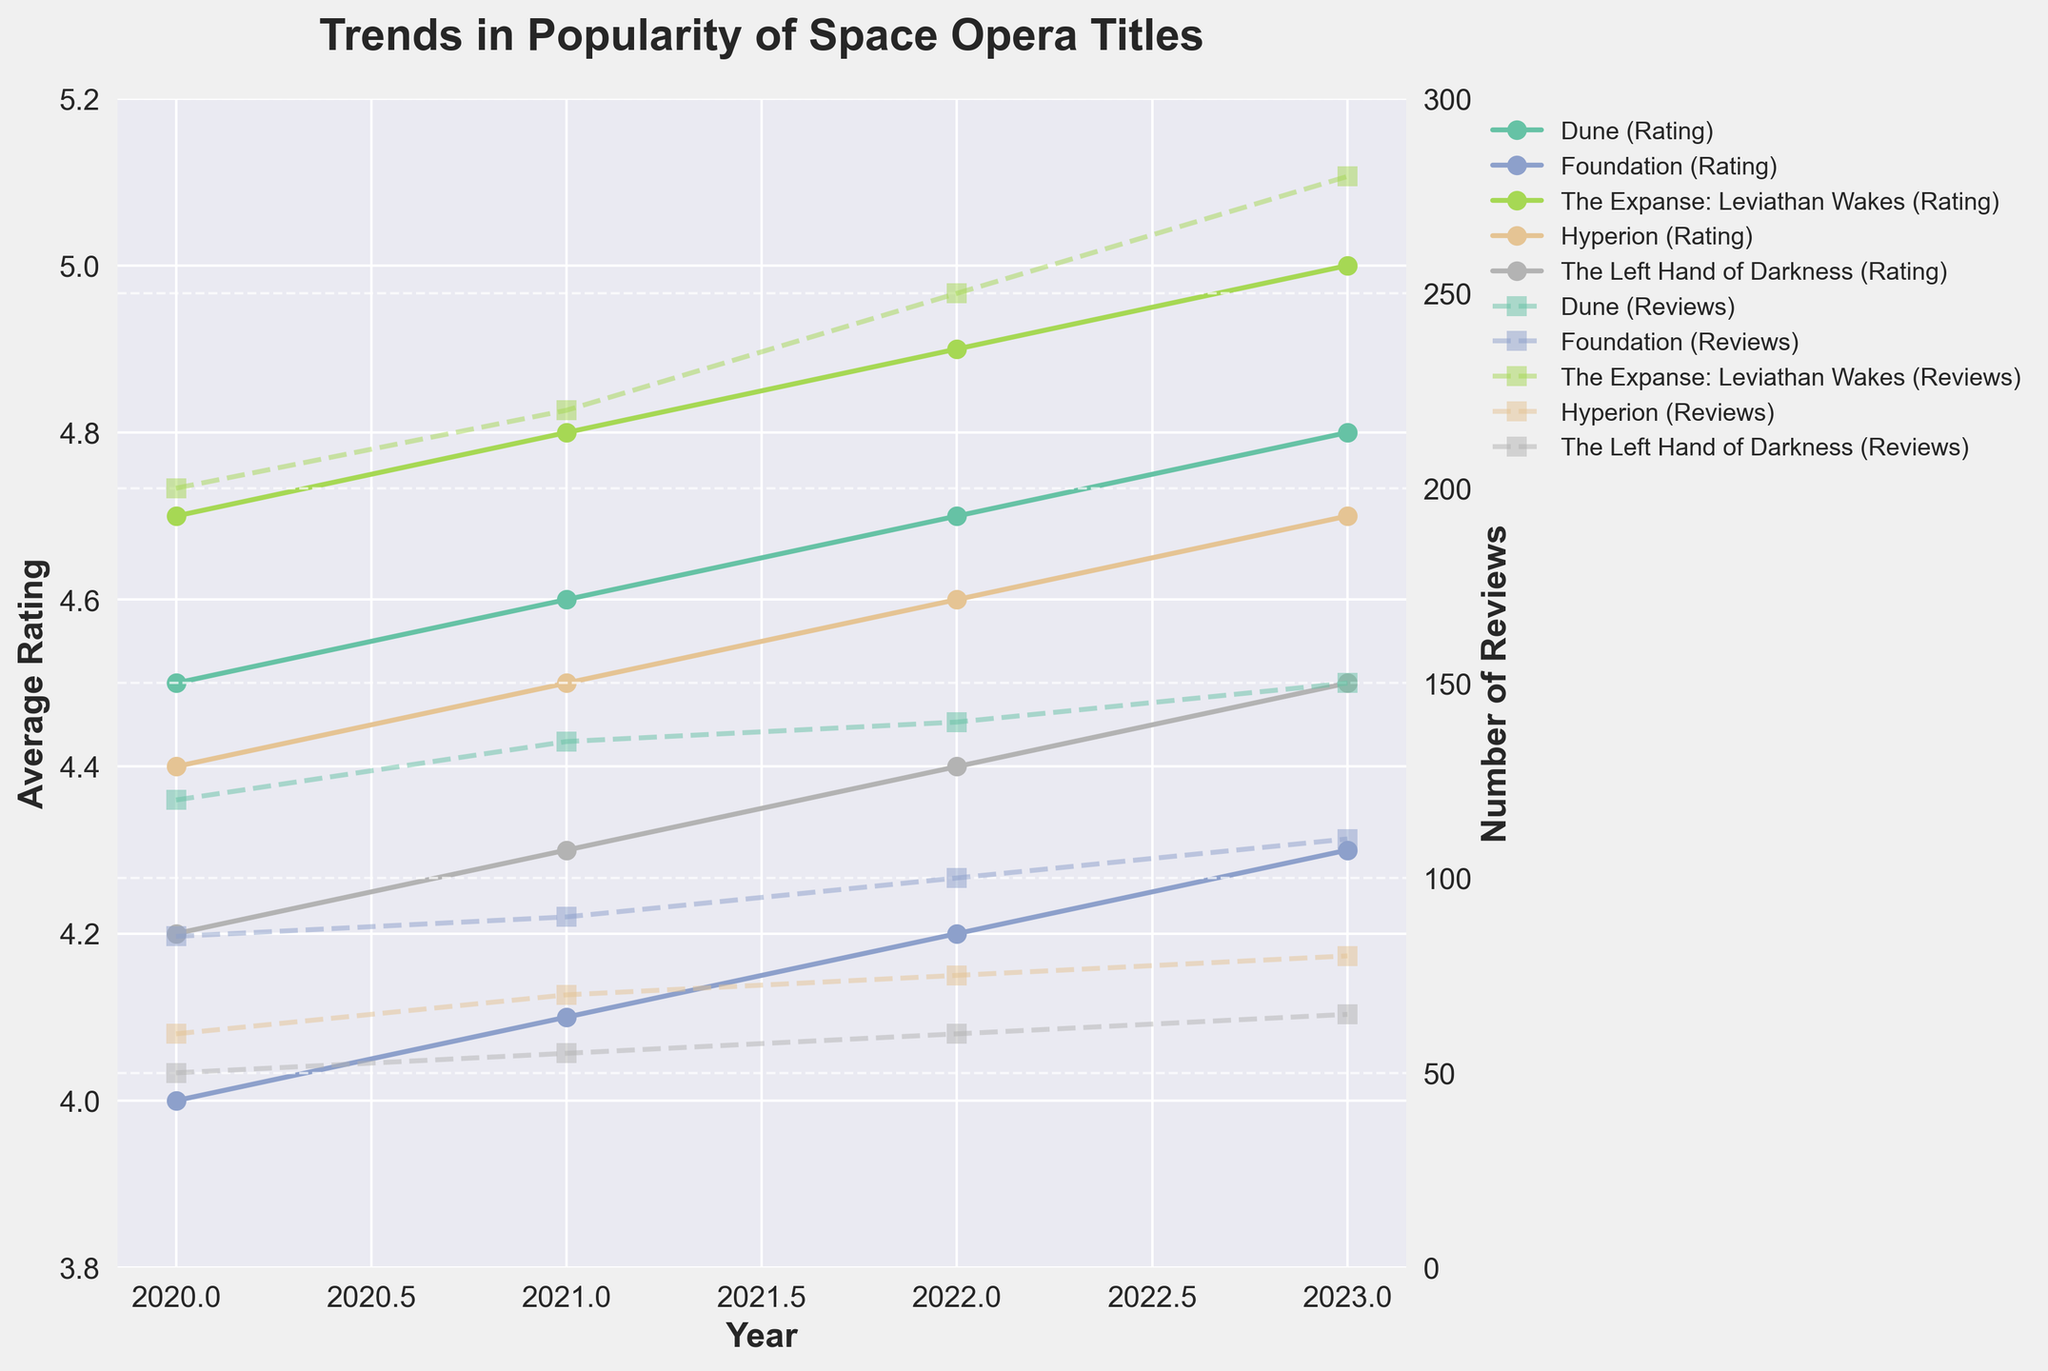what title has the highest average rating in 2023? By looking at the average ratings for the year 2023, "The Expanse: Leviathan Wakes" has the highest average rating of 5.0.
Answer: The Expanse: Leviathan Wakes Which year did "Foundation" have the lowest average rating? By plotting the average ratings of "Foundation" over the years, in 2020 it had the lowest average rating of 4.0.
Answer: 2020 What is the trend in the number of reviews for "Dune" from 2020 to 2023? By looking at the number of reviews for "Dune" over the years, it has increased from 120 in 2020 to 150 in 2023.
Answer: Increasing Between "Hyperion" and "The Left Hand of Darkness," which title has more reviews in 2022? By comparing the number of reviews for both books in 2022, "Hyperion" has 75 reviews, whereas "The Left Hand of Darkness" has 60 reviews.
Answer: Hyperion What is the average rating of "Hyperion" over the four years? Adding up the average ratings of "Hyperion" from 2020 to 2023 and dividing by 4: (4.4 + 4.5 + 4.6 + 4.7) / 4 = 18.2 / 4 = 4.55.
Answer: 4.55 In 2021, which title had the highest number of reviews and what was the number? By looking at the number of reviews for each title in 2021, "The Expanse: Leviathan Wakes" had the highest with 220 reviews.
Answer: The Expanse: Leviathan Wakes, 220 How many more reviews did "Dune" receive in 2023 compared to 2020? Subtract the number of reviews in 2020 from the number in 2023 for "Dune": 150 - 120 = 30.
Answer: 30 What is the overall trend in the average rating for "The Expanse: Leviathan Wakes" over the years? By observing the average ratings for "The Expanse: Leviathan Wakes" from 2020 to 2023, the ratings have increased from 4.7 to 5.0, showing an upward trend.
Answer: Upward trend Which title had consistent growth in reviews every year? Checking the year-over-year growth in the number of reviews for each title, "The Expanse: Leviathan Wakes" shows consistent growth in reviews from 2020 to 2023.
Answer: The Expanse: Leviathan Wakes 